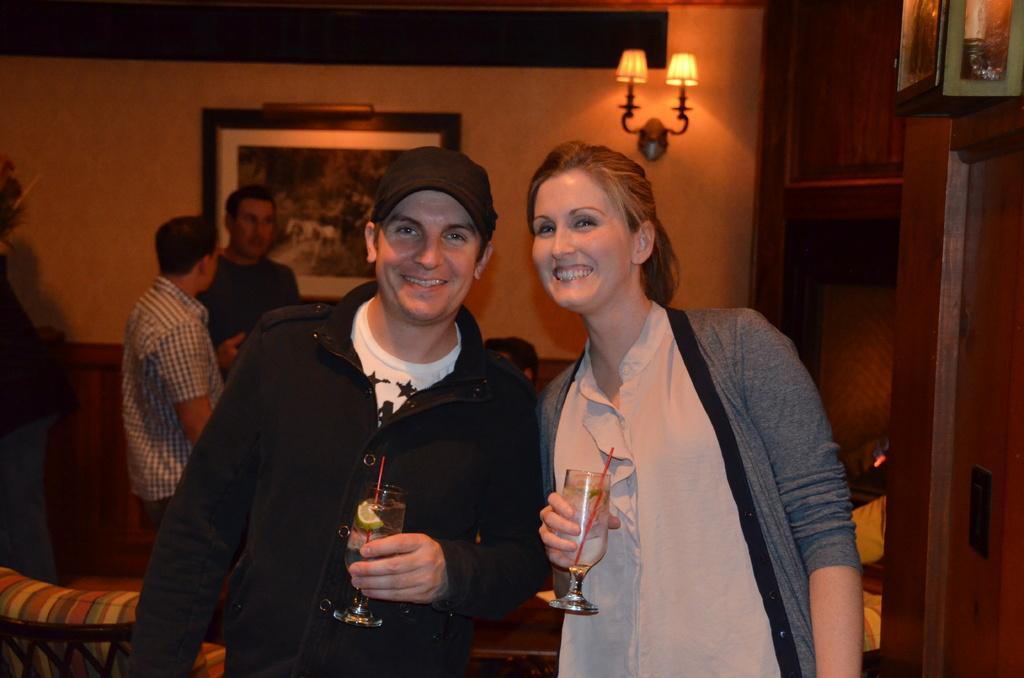Can you describe this image briefly? In this image I can see in the middle a man and a woman are holding the wine glasses and also they are smiling. On the left side two women are there, there is a photo frame on the wall. On the right side there are lights on the wall. 